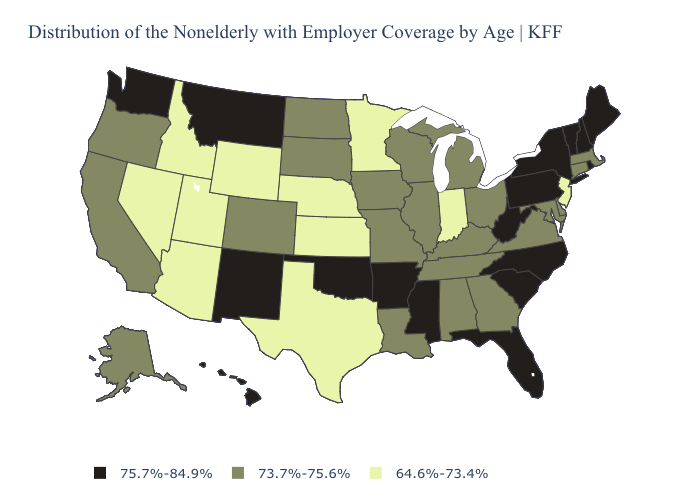What is the highest value in the USA?
Concise answer only. 75.7%-84.9%. What is the lowest value in the USA?
Write a very short answer. 64.6%-73.4%. Does Ohio have a lower value than Michigan?
Short answer required. No. Does the map have missing data?
Give a very brief answer. No. Does Alaska have a higher value than Wyoming?
Be succinct. Yes. Among the states that border Wyoming , which have the lowest value?
Write a very short answer. Idaho, Nebraska, Utah. What is the highest value in states that border Washington?
Quick response, please. 73.7%-75.6%. Name the states that have a value in the range 73.7%-75.6%?
Keep it brief. Alabama, Alaska, California, Colorado, Connecticut, Delaware, Georgia, Illinois, Iowa, Kentucky, Louisiana, Maryland, Massachusetts, Michigan, Missouri, North Dakota, Ohio, Oregon, South Dakota, Tennessee, Virginia, Wisconsin. Does Illinois have the same value as Indiana?
Keep it brief. No. What is the value of Kansas?
Be succinct. 64.6%-73.4%. What is the highest value in the West ?
Short answer required. 75.7%-84.9%. What is the lowest value in the South?
Answer briefly. 64.6%-73.4%. What is the lowest value in states that border New Hampshire?
Concise answer only. 73.7%-75.6%. What is the lowest value in states that border Kansas?
Give a very brief answer. 64.6%-73.4%. Does Kentucky have a lower value than Rhode Island?
Quick response, please. Yes. 